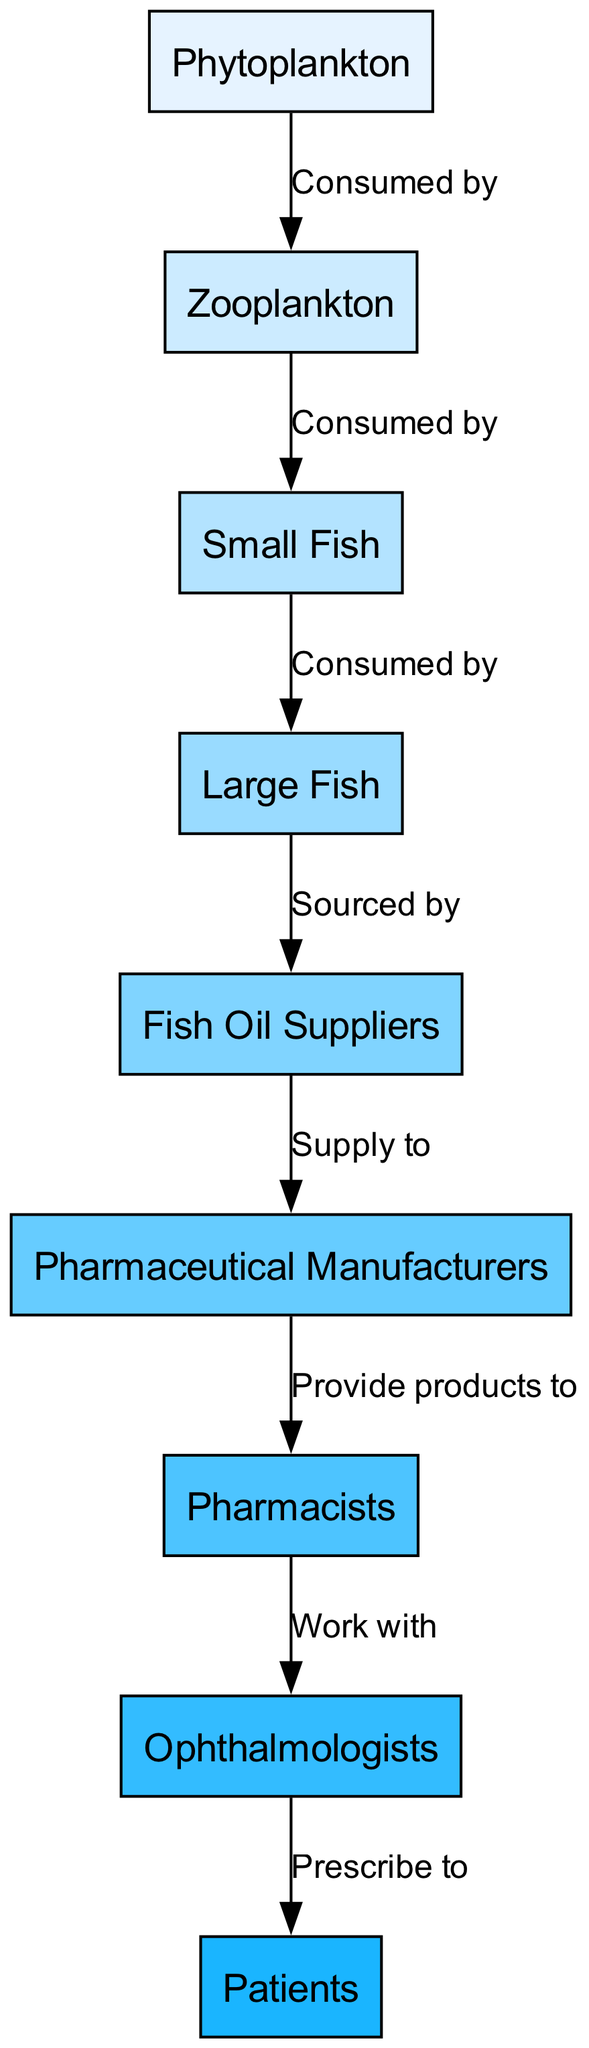What is the first node in the food chain? The first node is labeled "Phytoplankton," as it is the starting point of the food chain depicted in the diagram.
Answer: Phytoplankton How many nodes are there in the diagram? By counting all the individual nodes listed, there are a total of nine nodes in the diagram.
Answer: 9 What is the relationship between Zooplankton and Small Fish? The diagram shows that Zooplankton is "Consumed by" Small Fish, indicating a predator-prey relationship.
Answer: Consumed by Who provides products to pharmacists? The arrows indicate that Pharmaceutical Manufacturers provide products to Pharmacists, establishing a supply relationship between these two nodes.
Answer: Pharmaceutical Manufacturers What is sourced by Fish Oil Suppliers? The diagram specifies that Fish Oil Suppliers source from Large Fish, indicating that these suppliers rely on catching or harvesting large fish.
Answer: Large Fish How many steps are there from Phytoplankton to Patients? To find the number of steps, we can follow the flow: Phytoplankton → Zooplankton → Small Fish → Large Fish → Fish Oil Suppliers → Pharmaceutical Manufacturers → Pharmacists → Ophthalmologists → Patients. This results in a total of eight steps.
Answer: 8 Which node works closely with ophthalmologists? The arrow in the diagram indicates that Pharmacists work closely with Ophthalmologists, showing a professional relationship between them.
Answer: Pharmacists What is the final node in the food chain? The last node, represented at the end of the flow, is "Patients," indicating that they are the final recipients of the supply chain linked to omega-3 fatty acids.
Answer: Patients What type of relationship exists between Large Fish and Fish Oil Suppliers? The diagram specifies a "Sourced by" relationship, indicating that Fish Oil Suppliers depend on Large Fish for their source of omega-3 fatty acids.
Answer: Sourced by 